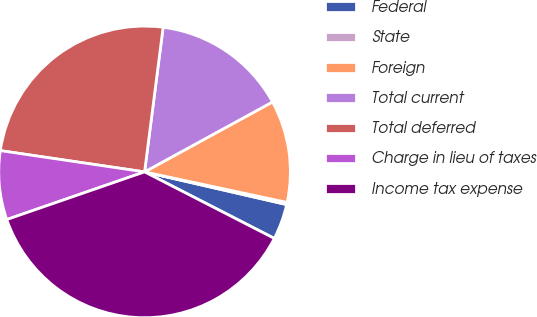Convert chart. <chart><loc_0><loc_0><loc_500><loc_500><pie_chart><fcel>Federal<fcel>State<fcel>Foreign<fcel>Total current<fcel>Total deferred<fcel>Charge in lieu of taxes<fcel>Income tax expense<nl><fcel>3.94%<fcel>0.24%<fcel>11.32%<fcel>15.01%<fcel>24.7%<fcel>7.63%<fcel>37.16%<nl></chart> 